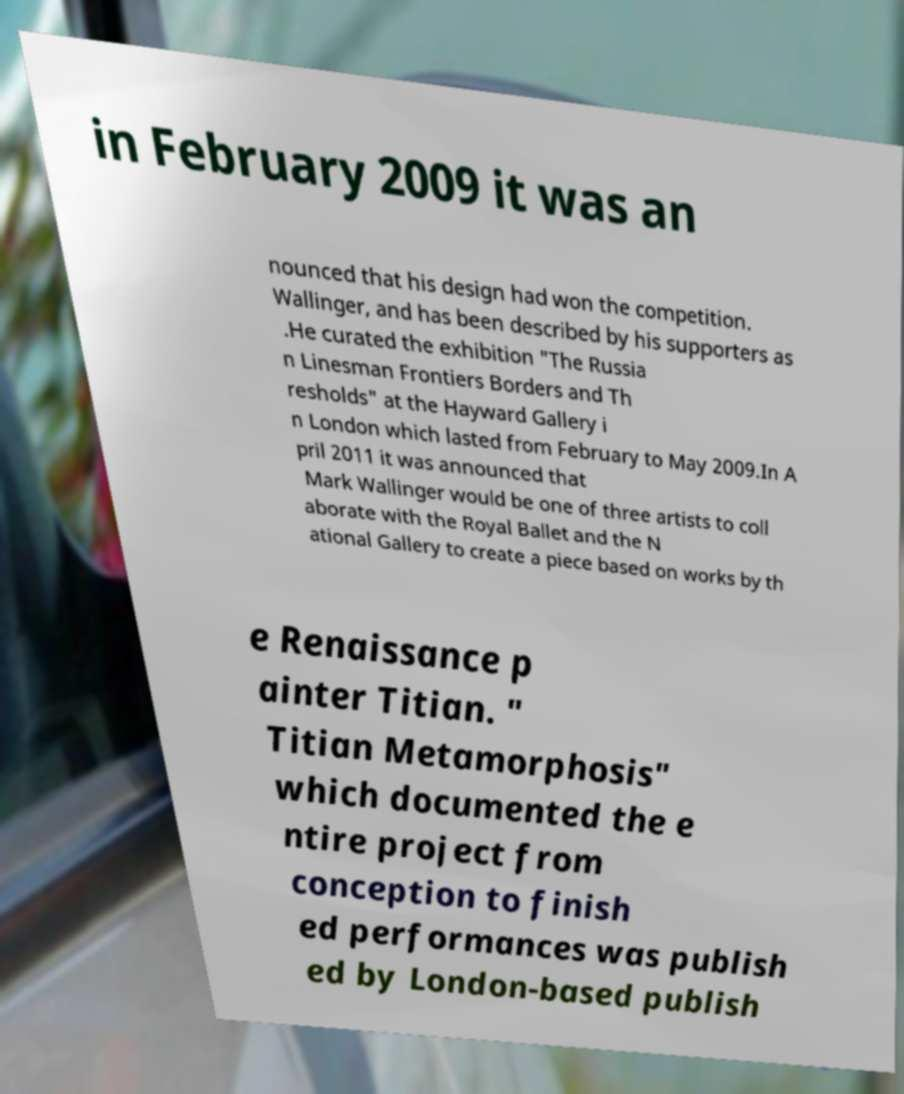What messages or text are displayed in this image? I need them in a readable, typed format. in February 2009 it was an nounced that his design had won the competition. Wallinger, and has been described by his supporters as .He curated the exhibition "The Russia n Linesman Frontiers Borders and Th resholds" at the Hayward Gallery i n London which lasted from February to May 2009.In A pril 2011 it was announced that Mark Wallinger would be one of three artists to coll aborate with the Royal Ballet and the N ational Gallery to create a piece based on works by th e Renaissance p ainter Titian. " Titian Metamorphosis" which documented the e ntire project from conception to finish ed performances was publish ed by London-based publish 